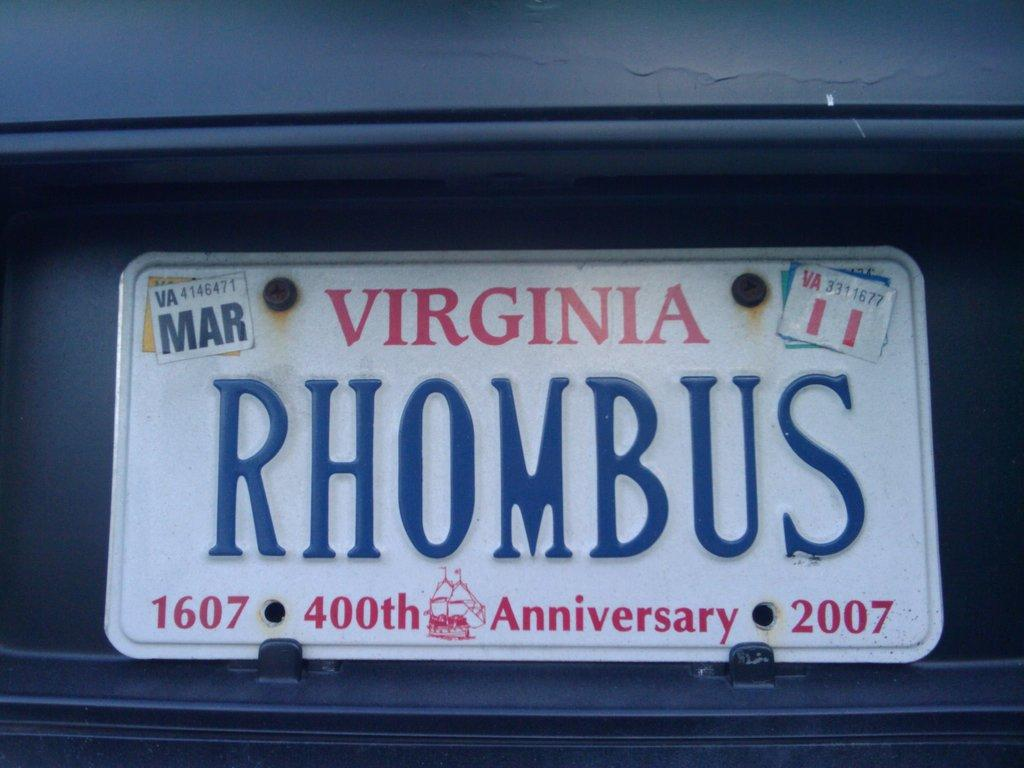Provide a one-sentence caption for the provided image. A 400th anniversary 2007 Virginia license plate says "RHOMBUS". 